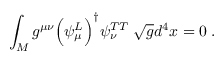Convert formula to latex. <formula><loc_0><loc_0><loc_500><loc_500>\int _ { M } g ^ { \mu \nu } \left ( \psi _ { \mu } ^ { L } \right ) ^ { \dagger } \psi _ { \nu } ^ { T T } \, \sqrt { g } d ^ { 4 } x = 0 \, .</formula> 